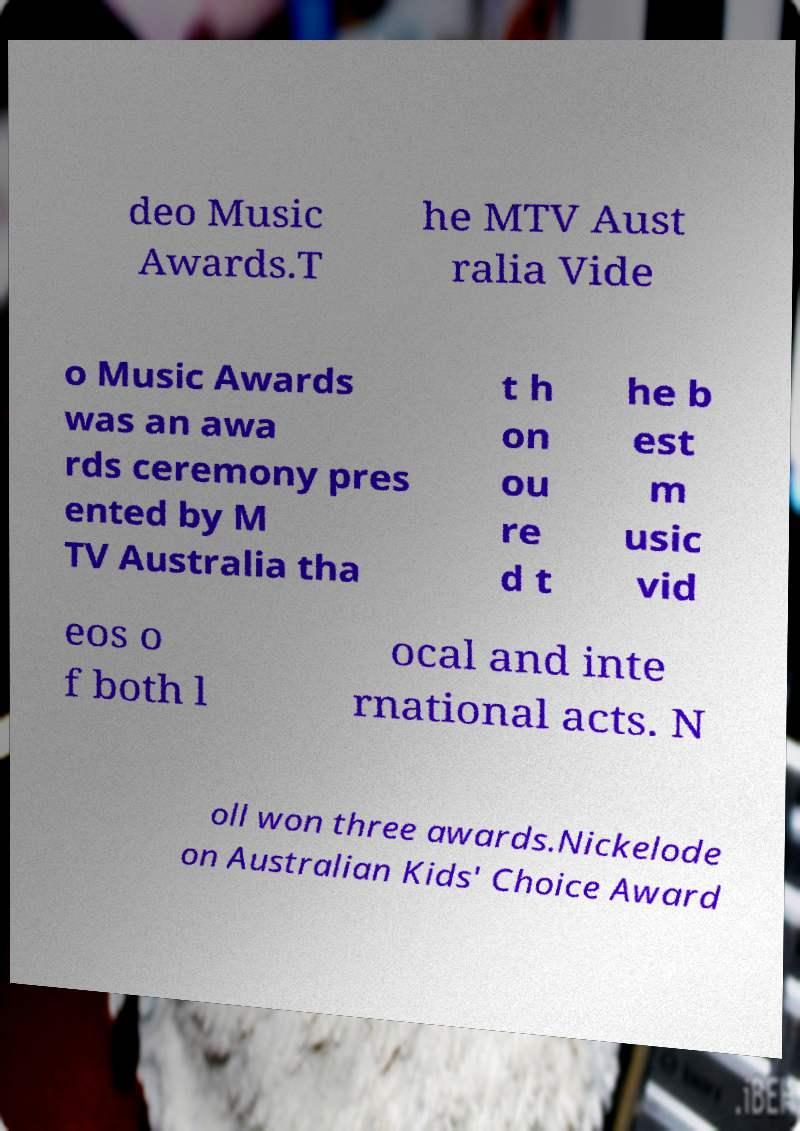There's text embedded in this image that I need extracted. Can you transcribe it verbatim? deo Music Awards.T he MTV Aust ralia Vide o Music Awards was an awa rds ceremony pres ented by M TV Australia tha t h on ou re d t he b est m usic vid eos o f both l ocal and inte rnational acts. N oll won three awards.Nickelode on Australian Kids' Choice Award 